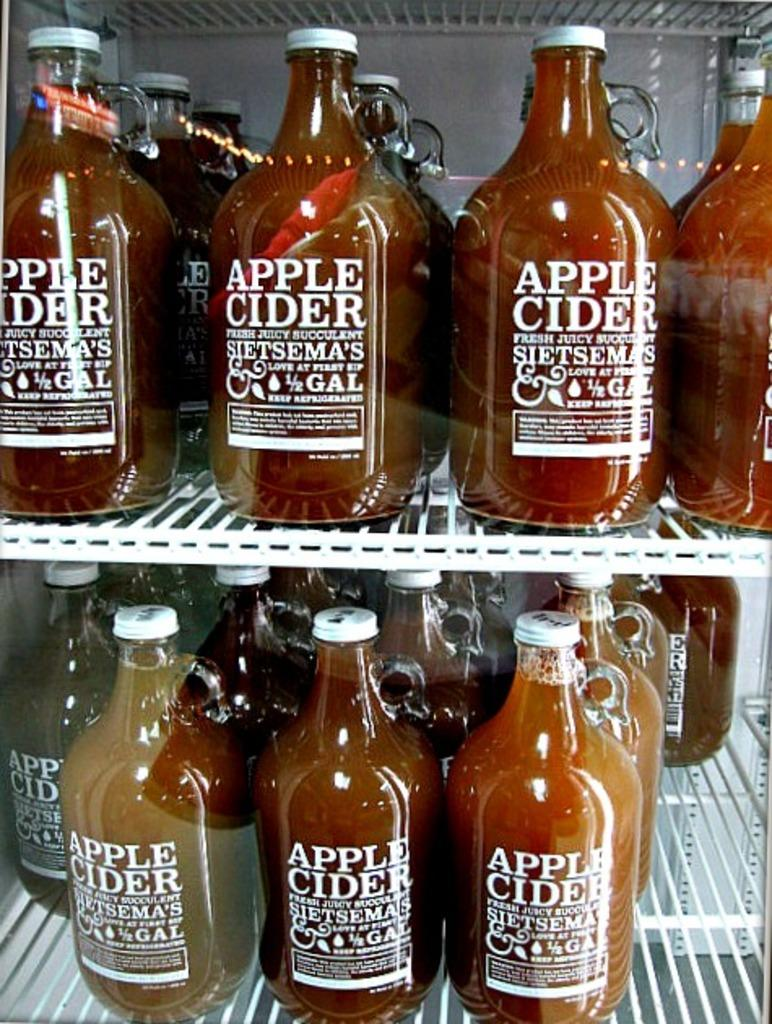<image>
Provide a brief description of the given image. Bottled up Apple Cider behind a glass screen. 